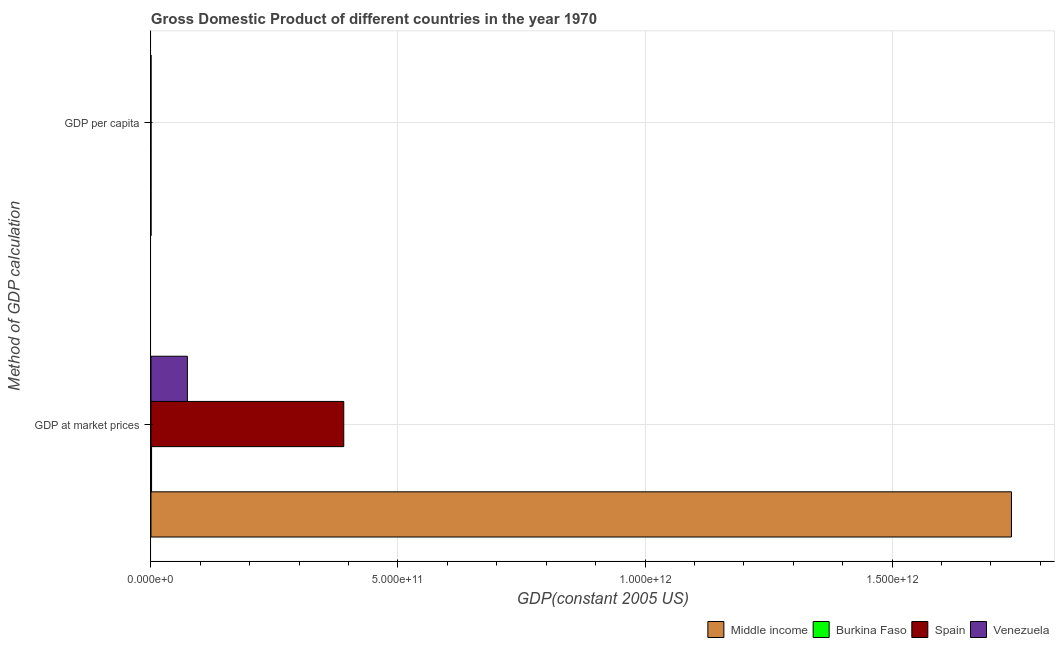How many groups of bars are there?
Ensure brevity in your answer.  2. Are the number of bars per tick equal to the number of legend labels?
Ensure brevity in your answer.  Yes. What is the label of the 2nd group of bars from the top?
Your answer should be compact. GDP at market prices. What is the gdp at market prices in Middle income?
Your response must be concise. 1.74e+12. Across all countries, what is the maximum gdp per capita?
Ensure brevity in your answer.  1.15e+04. Across all countries, what is the minimum gdp at market prices?
Provide a short and direct response. 1.22e+09. In which country was the gdp per capita minimum?
Offer a terse response. Burkina Faso. What is the total gdp per capita in the graph?
Give a very brief answer. 1.88e+04. What is the difference between the gdp per capita in Spain and that in Venezuela?
Provide a short and direct response. 5179.45. What is the difference between the gdp per capita in Middle income and the gdp at market prices in Spain?
Give a very brief answer. -3.90e+11. What is the average gdp per capita per country?
Provide a succinct answer. 4706.23. What is the difference between the gdp at market prices and gdp per capita in Burkina Faso?
Your answer should be compact. 1.22e+09. What is the ratio of the gdp per capita in Spain to that in Burkina Faso?
Keep it short and to the point. 53.11. In how many countries, is the gdp per capita greater than the average gdp per capita taken over all countries?
Your response must be concise. 2. What does the 3rd bar from the top in GDP per capita represents?
Make the answer very short. Burkina Faso. What does the 1st bar from the bottom in GDP at market prices represents?
Offer a terse response. Middle income. How many countries are there in the graph?
Give a very brief answer. 4. What is the difference between two consecutive major ticks on the X-axis?
Your response must be concise. 5.00e+11. Are the values on the major ticks of X-axis written in scientific E-notation?
Offer a terse response. Yes. Does the graph contain any zero values?
Your response must be concise. No. Does the graph contain grids?
Provide a short and direct response. Yes. How many legend labels are there?
Provide a short and direct response. 4. What is the title of the graph?
Make the answer very short. Gross Domestic Product of different countries in the year 1970. Does "French Polynesia" appear as one of the legend labels in the graph?
Ensure brevity in your answer.  No. What is the label or title of the X-axis?
Ensure brevity in your answer.  GDP(constant 2005 US). What is the label or title of the Y-axis?
Your response must be concise. Method of GDP calculation. What is the GDP(constant 2005 US) of Middle income in GDP at market prices?
Your answer should be very brief. 1.74e+12. What is the GDP(constant 2005 US) of Burkina Faso in GDP at market prices?
Ensure brevity in your answer.  1.22e+09. What is the GDP(constant 2005 US) of Spain in GDP at market prices?
Provide a short and direct response. 3.90e+11. What is the GDP(constant 2005 US) in Venezuela in GDP at market prices?
Your answer should be compact. 7.37e+1. What is the GDP(constant 2005 US) in Middle income in GDP per capita?
Your answer should be very brief. 705.53. What is the GDP(constant 2005 US) of Burkina Faso in GDP per capita?
Your answer should be very brief. 217.29. What is the GDP(constant 2005 US) of Spain in GDP per capita?
Your answer should be compact. 1.15e+04. What is the GDP(constant 2005 US) of Venezuela in GDP per capita?
Your response must be concise. 6361.33. Across all Method of GDP calculation, what is the maximum GDP(constant 2005 US) of Middle income?
Offer a terse response. 1.74e+12. Across all Method of GDP calculation, what is the maximum GDP(constant 2005 US) of Burkina Faso?
Provide a succinct answer. 1.22e+09. Across all Method of GDP calculation, what is the maximum GDP(constant 2005 US) in Spain?
Make the answer very short. 3.90e+11. Across all Method of GDP calculation, what is the maximum GDP(constant 2005 US) in Venezuela?
Provide a short and direct response. 7.37e+1. Across all Method of GDP calculation, what is the minimum GDP(constant 2005 US) in Middle income?
Keep it short and to the point. 705.53. Across all Method of GDP calculation, what is the minimum GDP(constant 2005 US) of Burkina Faso?
Offer a terse response. 217.29. Across all Method of GDP calculation, what is the minimum GDP(constant 2005 US) in Spain?
Make the answer very short. 1.15e+04. Across all Method of GDP calculation, what is the minimum GDP(constant 2005 US) of Venezuela?
Your answer should be very brief. 6361.33. What is the total GDP(constant 2005 US) of Middle income in the graph?
Keep it short and to the point. 1.74e+12. What is the total GDP(constant 2005 US) in Burkina Faso in the graph?
Your answer should be very brief. 1.22e+09. What is the total GDP(constant 2005 US) of Spain in the graph?
Ensure brevity in your answer.  3.90e+11. What is the total GDP(constant 2005 US) of Venezuela in the graph?
Provide a short and direct response. 7.37e+1. What is the difference between the GDP(constant 2005 US) in Middle income in GDP at market prices and that in GDP per capita?
Give a very brief answer. 1.74e+12. What is the difference between the GDP(constant 2005 US) of Burkina Faso in GDP at market prices and that in GDP per capita?
Offer a very short reply. 1.22e+09. What is the difference between the GDP(constant 2005 US) in Spain in GDP at market prices and that in GDP per capita?
Provide a short and direct response. 3.90e+11. What is the difference between the GDP(constant 2005 US) in Venezuela in GDP at market prices and that in GDP per capita?
Provide a succinct answer. 7.37e+1. What is the difference between the GDP(constant 2005 US) in Middle income in GDP at market prices and the GDP(constant 2005 US) in Burkina Faso in GDP per capita?
Make the answer very short. 1.74e+12. What is the difference between the GDP(constant 2005 US) of Middle income in GDP at market prices and the GDP(constant 2005 US) of Spain in GDP per capita?
Your response must be concise. 1.74e+12. What is the difference between the GDP(constant 2005 US) in Middle income in GDP at market prices and the GDP(constant 2005 US) in Venezuela in GDP per capita?
Offer a terse response. 1.74e+12. What is the difference between the GDP(constant 2005 US) of Burkina Faso in GDP at market prices and the GDP(constant 2005 US) of Spain in GDP per capita?
Offer a terse response. 1.22e+09. What is the difference between the GDP(constant 2005 US) of Burkina Faso in GDP at market prices and the GDP(constant 2005 US) of Venezuela in GDP per capita?
Make the answer very short. 1.22e+09. What is the difference between the GDP(constant 2005 US) in Spain in GDP at market prices and the GDP(constant 2005 US) in Venezuela in GDP per capita?
Keep it short and to the point. 3.90e+11. What is the average GDP(constant 2005 US) in Middle income per Method of GDP calculation?
Keep it short and to the point. 8.71e+11. What is the average GDP(constant 2005 US) in Burkina Faso per Method of GDP calculation?
Ensure brevity in your answer.  6.11e+08. What is the average GDP(constant 2005 US) in Spain per Method of GDP calculation?
Give a very brief answer. 1.95e+11. What is the average GDP(constant 2005 US) in Venezuela per Method of GDP calculation?
Your answer should be very brief. 3.69e+1. What is the difference between the GDP(constant 2005 US) of Middle income and GDP(constant 2005 US) of Burkina Faso in GDP at market prices?
Provide a short and direct response. 1.74e+12. What is the difference between the GDP(constant 2005 US) in Middle income and GDP(constant 2005 US) in Spain in GDP at market prices?
Keep it short and to the point. 1.35e+12. What is the difference between the GDP(constant 2005 US) of Middle income and GDP(constant 2005 US) of Venezuela in GDP at market prices?
Make the answer very short. 1.67e+12. What is the difference between the GDP(constant 2005 US) of Burkina Faso and GDP(constant 2005 US) of Spain in GDP at market prices?
Your response must be concise. -3.89e+11. What is the difference between the GDP(constant 2005 US) of Burkina Faso and GDP(constant 2005 US) of Venezuela in GDP at market prices?
Provide a succinct answer. -7.25e+1. What is the difference between the GDP(constant 2005 US) in Spain and GDP(constant 2005 US) in Venezuela in GDP at market prices?
Make the answer very short. 3.17e+11. What is the difference between the GDP(constant 2005 US) of Middle income and GDP(constant 2005 US) of Burkina Faso in GDP per capita?
Offer a terse response. 488.24. What is the difference between the GDP(constant 2005 US) of Middle income and GDP(constant 2005 US) of Spain in GDP per capita?
Provide a short and direct response. -1.08e+04. What is the difference between the GDP(constant 2005 US) of Middle income and GDP(constant 2005 US) of Venezuela in GDP per capita?
Your response must be concise. -5655.79. What is the difference between the GDP(constant 2005 US) of Burkina Faso and GDP(constant 2005 US) of Spain in GDP per capita?
Your answer should be very brief. -1.13e+04. What is the difference between the GDP(constant 2005 US) of Burkina Faso and GDP(constant 2005 US) of Venezuela in GDP per capita?
Offer a very short reply. -6144.04. What is the difference between the GDP(constant 2005 US) of Spain and GDP(constant 2005 US) of Venezuela in GDP per capita?
Your answer should be very brief. 5179.45. What is the ratio of the GDP(constant 2005 US) of Middle income in GDP at market prices to that in GDP per capita?
Provide a succinct answer. 2.47e+09. What is the ratio of the GDP(constant 2005 US) of Burkina Faso in GDP at market prices to that in GDP per capita?
Offer a terse response. 5.62e+06. What is the ratio of the GDP(constant 2005 US) of Spain in GDP at market prices to that in GDP per capita?
Your response must be concise. 3.38e+07. What is the ratio of the GDP(constant 2005 US) of Venezuela in GDP at market prices to that in GDP per capita?
Your answer should be very brief. 1.16e+07. What is the difference between the highest and the second highest GDP(constant 2005 US) of Middle income?
Your answer should be very brief. 1.74e+12. What is the difference between the highest and the second highest GDP(constant 2005 US) of Burkina Faso?
Provide a succinct answer. 1.22e+09. What is the difference between the highest and the second highest GDP(constant 2005 US) of Spain?
Provide a succinct answer. 3.90e+11. What is the difference between the highest and the second highest GDP(constant 2005 US) in Venezuela?
Provide a succinct answer. 7.37e+1. What is the difference between the highest and the lowest GDP(constant 2005 US) of Middle income?
Give a very brief answer. 1.74e+12. What is the difference between the highest and the lowest GDP(constant 2005 US) in Burkina Faso?
Give a very brief answer. 1.22e+09. What is the difference between the highest and the lowest GDP(constant 2005 US) of Spain?
Your response must be concise. 3.90e+11. What is the difference between the highest and the lowest GDP(constant 2005 US) in Venezuela?
Ensure brevity in your answer.  7.37e+1. 